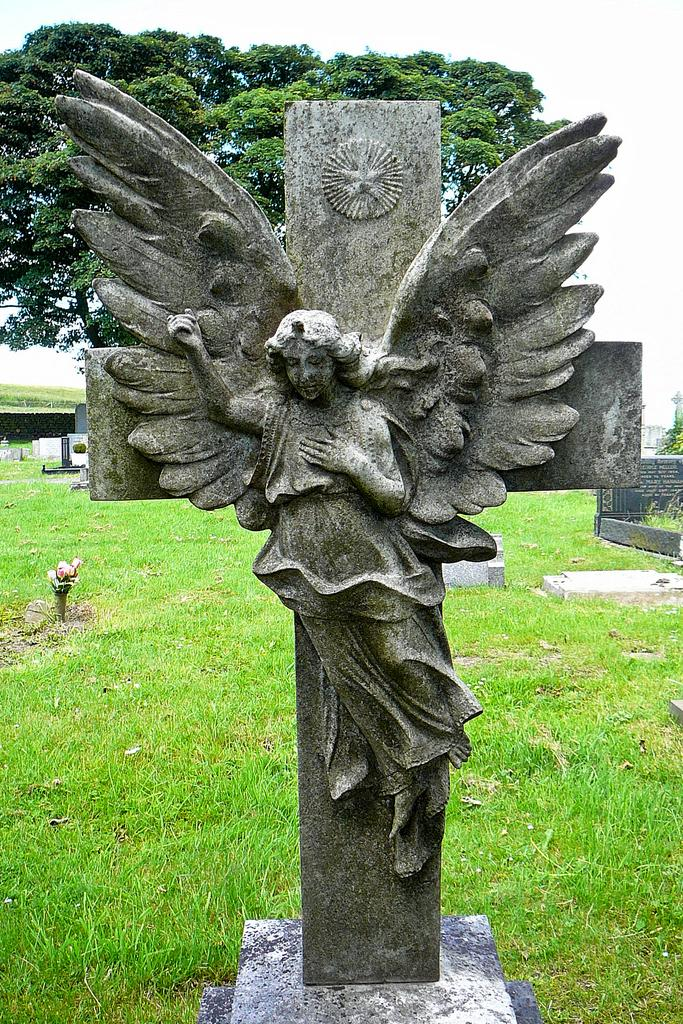What is the main subject in the image? There is a statue in the image. What is the statue standing on? The statue is on a stone. What can be seen behind the statue? There are trees, a wall, and grass behind the statue. What is visible in the background of the image? The sky is visible in the background of the image. How many mice are climbing on the statue in the image? There are no mice present in the image; the statue is not interacting with any mice. Can you see an icicle hanging from the statue in the image? There is no icicle visible in the image; the statue is not associated with any icicles. 